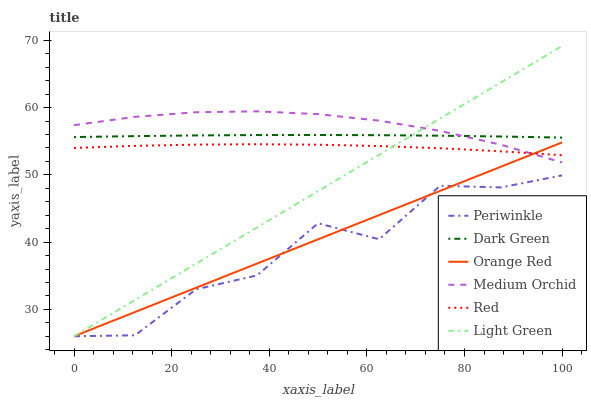Does Periwinkle have the minimum area under the curve?
Answer yes or no. Yes. Does Medium Orchid have the maximum area under the curve?
Answer yes or no. Yes. Does Light Green have the minimum area under the curve?
Answer yes or no. No. Does Light Green have the maximum area under the curve?
Answer yes or no. No. Is Orange Red the smoothest?
Answer yes or no. Yes. Is Periwinkle the roughest?
Answer yes or no. Yes. Is Light Green the smoothest?
Answer yes or no. No. Is Light Green the roughest?
Answer yes or no. No. Does Periwinkle have the lowest value?
Answer yes or no. Yes. Does Red have the lowest value?
Answer yes or no. No. Does Light Green have the highest value?
Answer yes or no. Yes. Does Periwinkle have the highest value?
Answer yes or no. No. Is Periwinkle less than Medium Orchid?
Answer yes or no. Yes. Is Medium Orchid greater than Periwinkle?
Answer yes or no. Yes. Does Light Green intersect Red?
Answer yes or no. Yes. Is Light Green less than Red?
Answer yes or no. No. Is Light Green greater than Red?
Answer yes or no. No. Does Periwinkle intersect Medium Orchid?
Answer yes or no. No. 